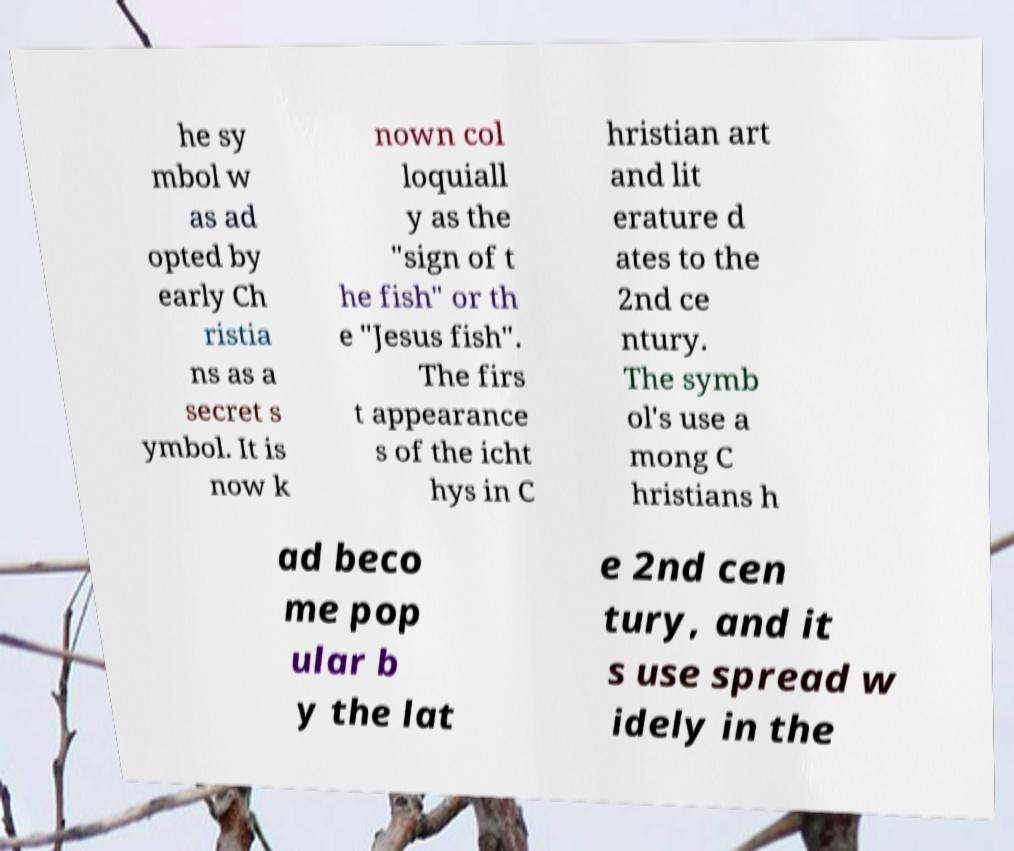Please identify and transcribe the text found in this image. he sy mbol w as ad opted by early Ch ristia ns as a secret s ymbol. It is now k nown col loquiall y as the "sign of t he fish" or th e "Jesus fish". The firs t appearance s of the icht hys in C hristian art and lit erature d ates to the 2nd ce ntury. The symb ol's use a mong C hristians h ad beco me pop ular b y the lat e 2nd cen tury, and it s use spread w idely in the 